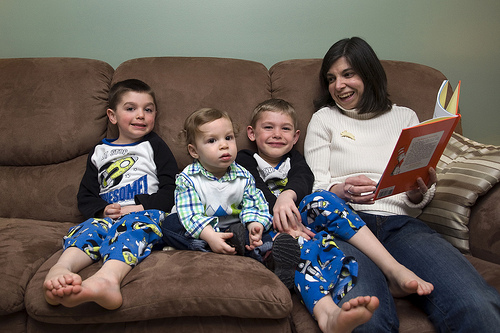<image>
Is there a child next to the mother? No. The child is not positioned next to the mother. They are located in different areas of the scene. Is there a baby on the sofa? Yes. Looking at the image, I can see the baby is positioned on top of the sofa, with the sofa providing support. Is the boy on the lady? No. The boy is not positioned on the lady. They may be near each other, but the boy is not supported by or resting on top of the lady. Where is the pajama bottoms in relation to the boy? Is it on the boy? No. The pajama bottoms is not positioned on the boy. They may be near each other, but the pajama bottoms is not supported by or resting on top of the boy. 